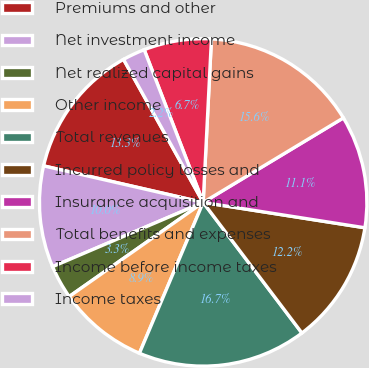<chart> <loc_0><loc_0><loc_500><loc_500><pie_chart><fcel>Premiums and other<fcel>Net investment income<fcel>Net realized capital gains<fcel>Other income<fcel>Total revenues<fcel>Incurred policy losses and<fcel>Insurance acquisition and<fcel>Total benefits and expenses<fcel>Income before income taxes<fcel>Income taxes<nl><fcel>13.33%<fcel>10.0%<fcel>3.33%<fcel>8.89%<fcel>16.67%<fcel>12.22%<fcel>11.11%<fcel>15.56%<fcel>6.67%<fcel>2.22%<nl></chart> 